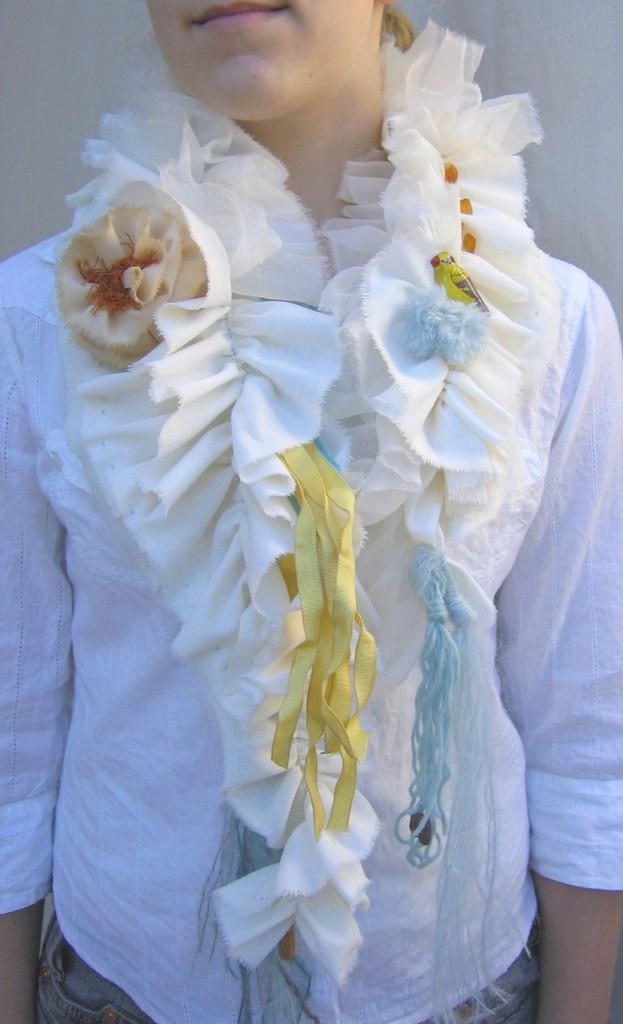What is the main subject of the image? There is a lady in the image. Can you describe the lady's attire? The lady is wearing a white dress. What type of food is the lady pointing to in the image? There is no food present in the image, nor is the lady pointing to anything. 